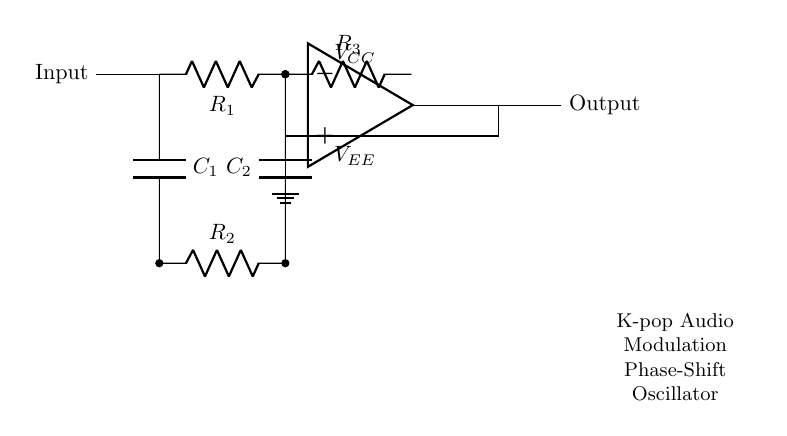What type of components are used in this circuit? The circuit diagram shows resistors and capacitors as the main components. This can be identified from the symbols for R and C, which indicate resistive and capacitive elements, respectively.
Answer: Resistors and capacitors What is the purpose of the operational amplifier in this circuit? The operational amplifier amplifies the input signal and is integral to the oscillation process in the phase-shift oscillator configuration, which is designed for generating audio modulation effects.
Answer: Amplification What is the total number of resistors in the circuit? By counting the symbols for resistors labeled R along the diagram, one can see there are three resistors connected in different places.
Answer: Three How many capacitors are present in this oscillator circuit? The circuit diagram features two capacitors, which are labeled C. These are clearly illustrated in the connections within the circuit.
Answer: Two What type of oscillator is depicted in this diagram? The circuit is specifically a phase-shift oscillator, which can be inferred from the inclusion of both resistors and capacitors that create the necessary phase shift for oscillation.
Answer: Phase-shift oscillator What does the output node represent in this circuit? The output node, indicated in the diagram, represents where the modified audio signal can be taken after processing through the circuit, delivering the modulation effect.
Answer: Output signal 